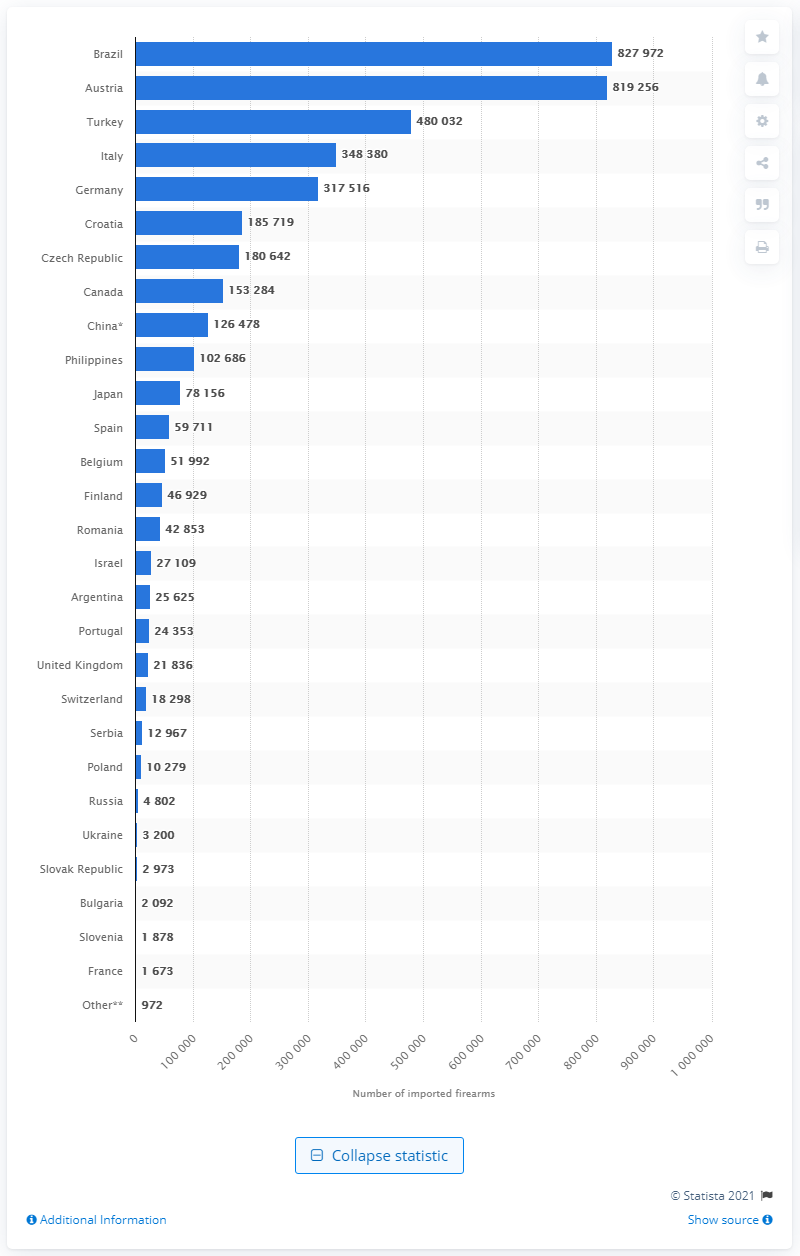Draw attention to some important aspects in this diagram. Brazil was the country that imported the most firearms into the United States in 2019. 